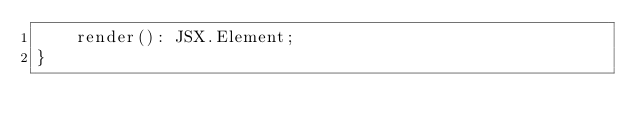<code> <loc_0><loc_0><loc_500><loc_500><_TypeScript_>    render(): JSX.Element;
}
</code> 